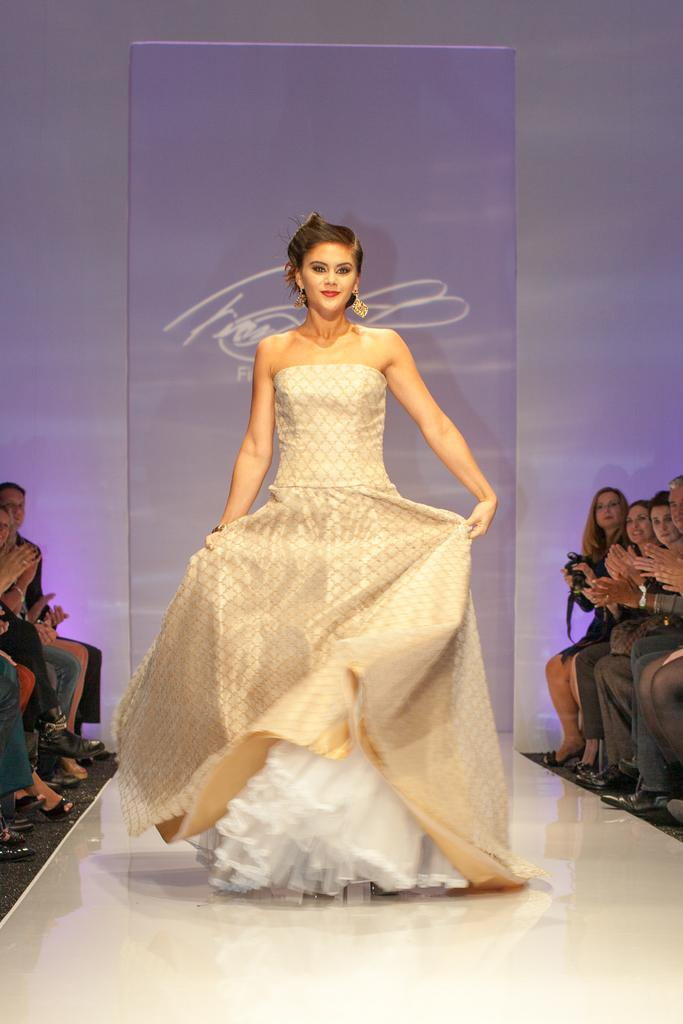What is the woman in the image doing? There is a woman walking in the image. What are the people around the woman doing? The seated people are clapping with their hands. Can you describe the background of the image? There is an advertisement hoarding visible in the background. Can you describe the waves crashing on the shore in the image? There are no waves or shore visible in the image; it features a woman walking with people seated around her and an advertisement hoarding in the background. 